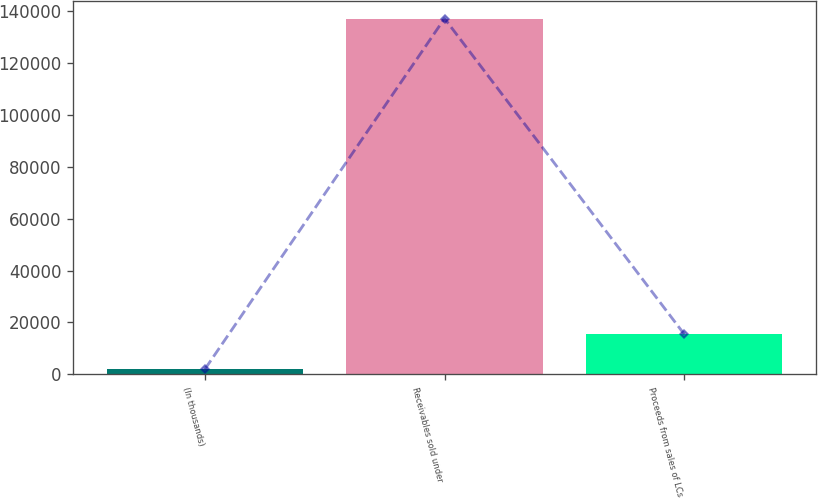Convert chart. <chart><loc_0><loc_0><loc_500><loc_500><bar_chart><fcel>(In thousands)<fcel>Receivables sold under<fcel>Proceeds from sales of LCs<nl><fcel>2015<fcel>137285<fcel>15542<nl></chart> 